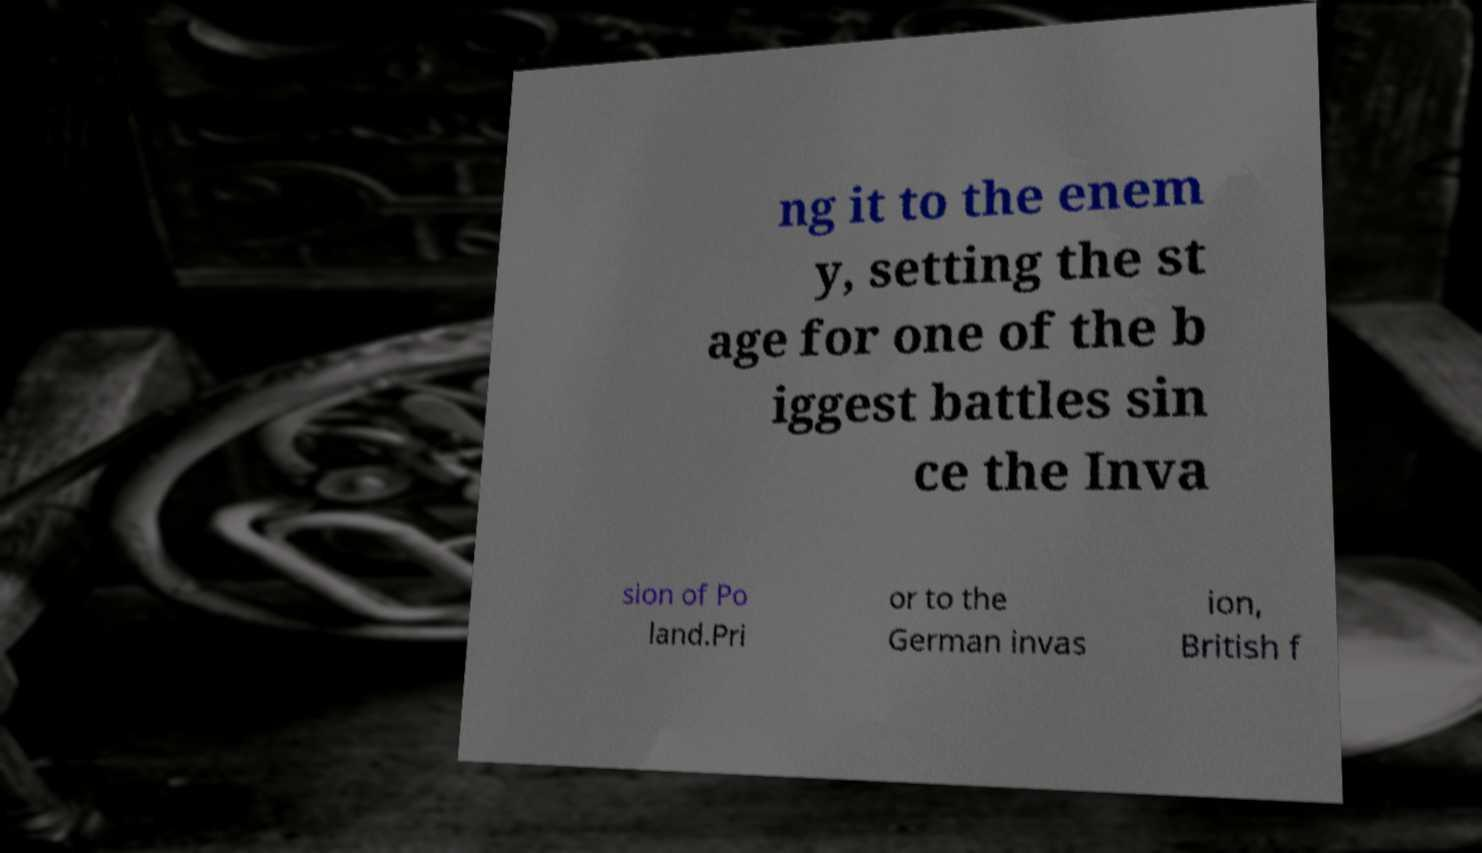Can you read and provide the text displayed in the image?This photo seems to have some interesting text. Can you extract and type it out for me? ng it to the enem y, setting the st age for one of the b iggest battles sin ce the Inva sion of Po land.Pri or to the German invas ion, British f 